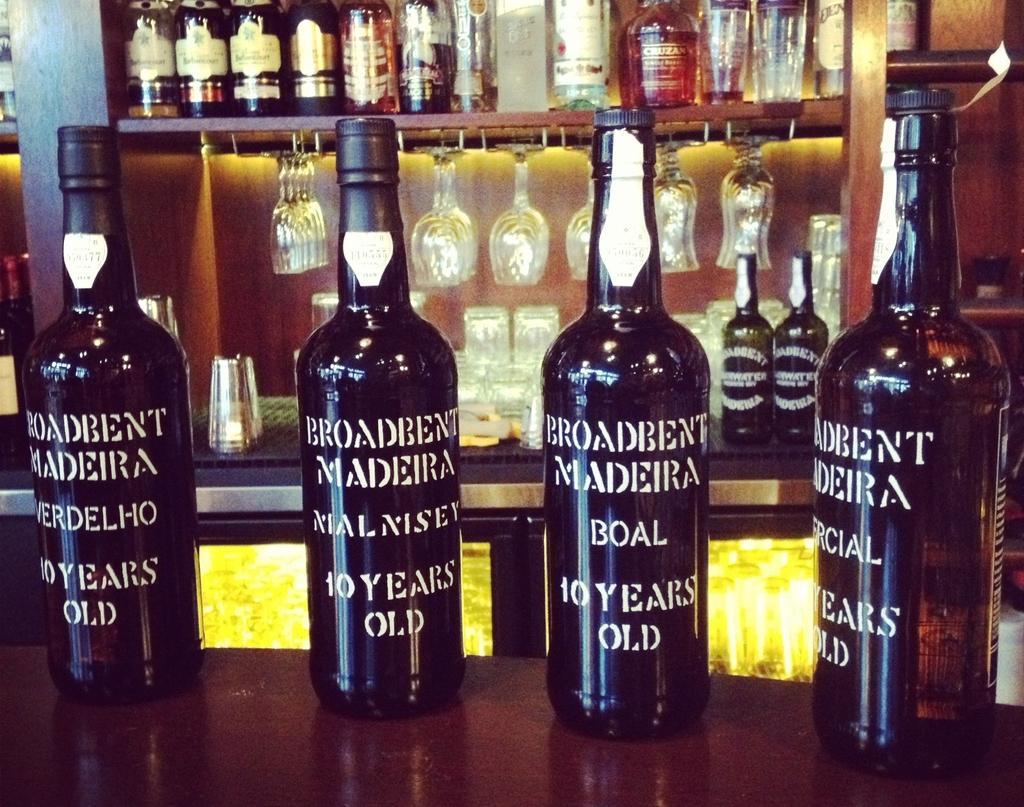<image>
Present a compact description of the photo's key features. Four bottles of 10 year old Broadbent Madeira wines in four flavors: Verdelho, Malnisey, Boal, Comercial 